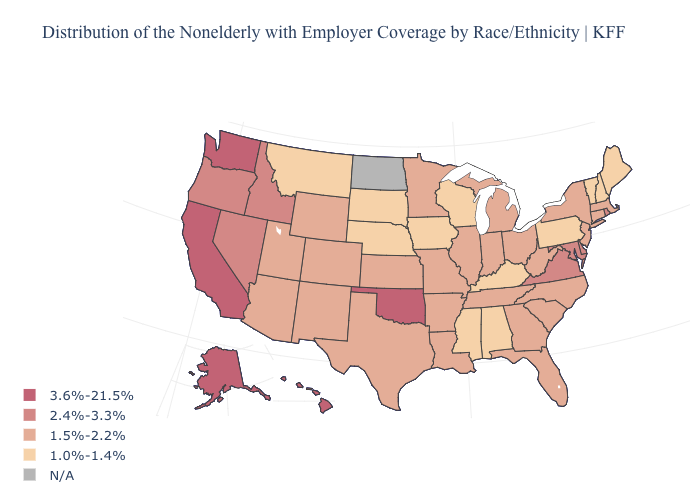How many symbols are there in the legend?
Give a very brief answer. 5. What is the value of Ohio?
Short answer required. 1.5%-2.2%. What is the highest value in the USA?
Concise answer only. 3.6%-21.5%. Name the states that have a value in the range 2.4%-3.3%?
Keep it brief. Delaware, Idaho, Maryland, Nevada, Oregon, Rhode Island, Virginia. Which states have the lowest value in the USA?
Keep it brief. Alabama, Iowa, Kentucky, Maine, Mississippi, Montana, Nebraska, New Hampshire, Pennsylvania, South Dakota, Vermont, Wisconsin. Does Alaska have the highest value in the USA?
Answer briefly. Yes. What is the value of Connecticut?
Short answer required. 1.5%-2.2%. What is the value of Colorado?
Keep it brief. 1.5%-2.2%. Among the states that border Oklahoma , which have the highest value?
Give a very brief answer. Arkansas, Colorado, Kansas, Missouri, New Mexico, Texas. What is the lowest value in the Northeast?
Concise answer only. 1.0%-1.4%. Among the states that border Michigan , does Ohio have the highest value?
Give a very brief answer. Yes. What is the value of Arkansas?
Quick response, please. 1.5%-2.2%. What is the value of Illinois?
Concise answer only. 1.5%-2.2%. Does Alaska have the highest value in the West?
Short answer required. Yes. 